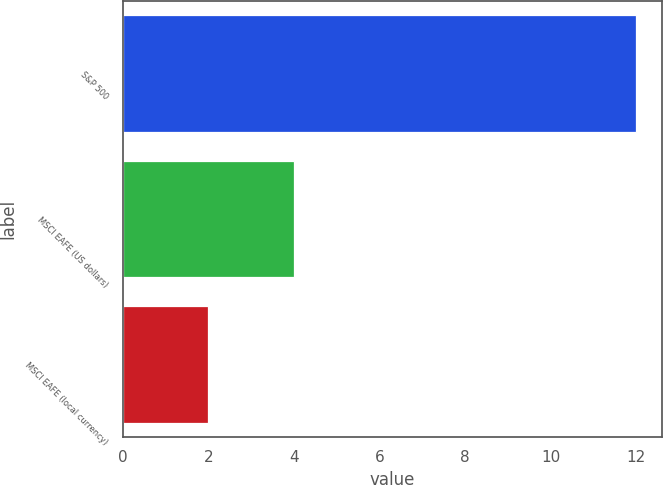Convert chart to OTSL. <chart><loc_0><loc_0><loc_500><loc_500><bar_chart><fcel>S&P 500<fcel>MSCI EAFE (US dollars)<fcel>MSCI EAFE (local currency)<nl><fcel>12<fcel>4<fcel>2<nl></chart> 